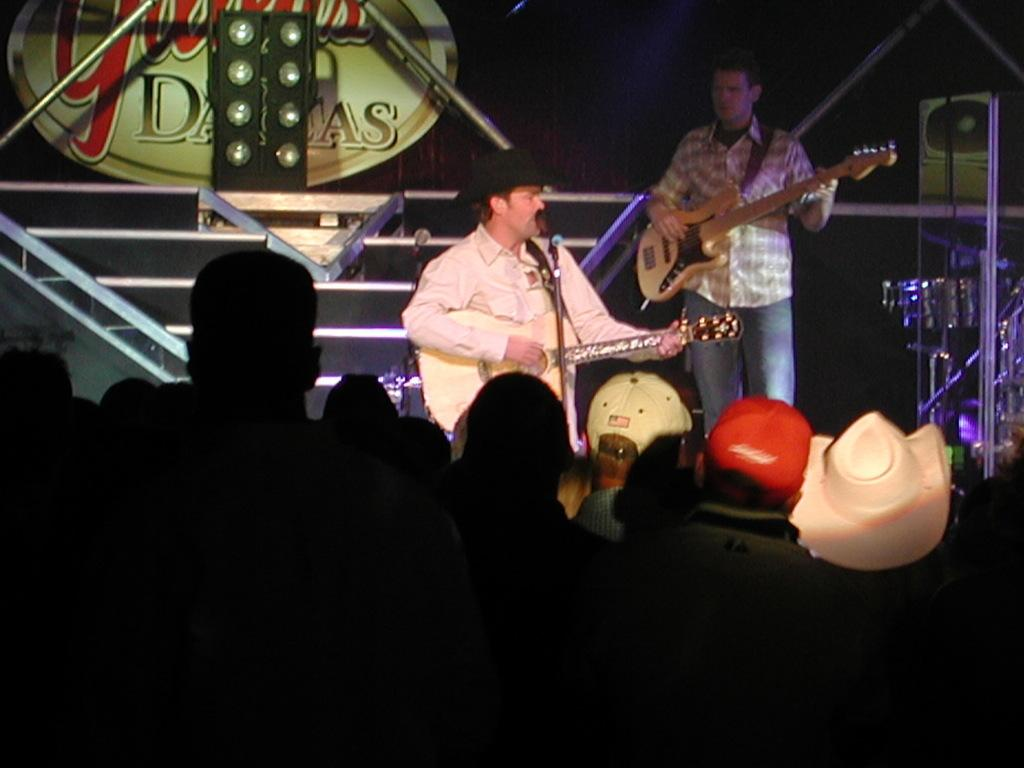What can be seen in the background of the image? There is a board and speakers in the background of the image. What are the persons in the image doing? The persons in the image are playing guitars. What is the purpose of the microphone in the image? The microphone is likely used for amplifying sound during the performance. Who is present in the front portion of the image? There is an audience visible in the front portion of the image. What type of drug is being sold by the person with the haircut in the image? There is no person with a haircut selling drugs in the image. Additionally, no drugs are mentioned or depicted in the image. 